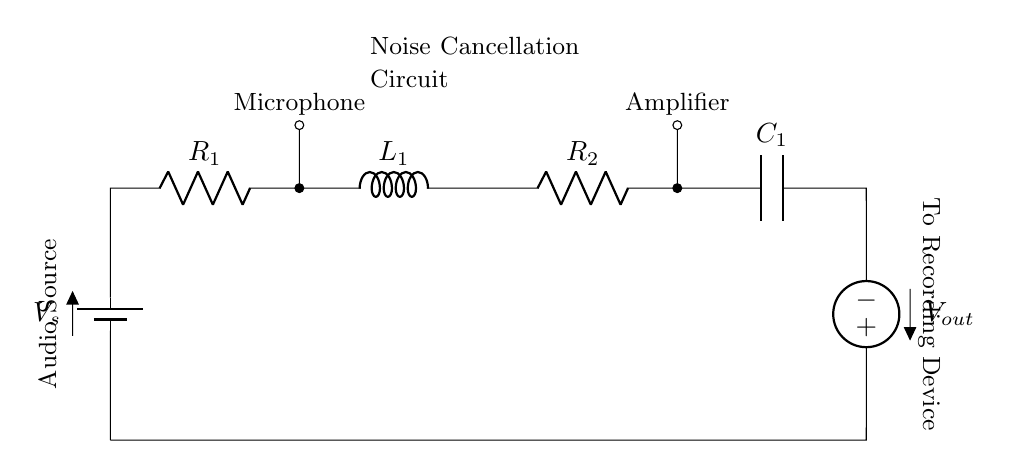What is the voltage source in this circuit? The circuit has a voltage source represented as V_s, which is the battery providing electrical energy.
Answer: V_s How many resistors are present in the circuit? There are two resistors labeled as R_1 and R_2, which are components providing resistance in the circuit.
Answer: 2 What component follows the amplifier in the circuit? The component that follows the amplifier is the capacitor labeled C_1, which is part of the noise cancellation functionality.
Answer: C_1 What is the role of the inductor in this circuit? The inductor labeled L_1 is situated in the circuit and is used to store energy in a magnetic field, which is essential for filtering and noise cancellation.
Answer: To filter noise What type of circuit is this? The circuit consists of components connected in series, where the current flows through each component sequentially.
Answer: Series How does the configuration of this circuit affect noise cancellation? The series arrangement allows all components to work together in filtering noise, with the combination of resistors, inductors, and capacitors helping to adjust frequencies and reduce undesired sounds.
Answer: Filters noise effectively 